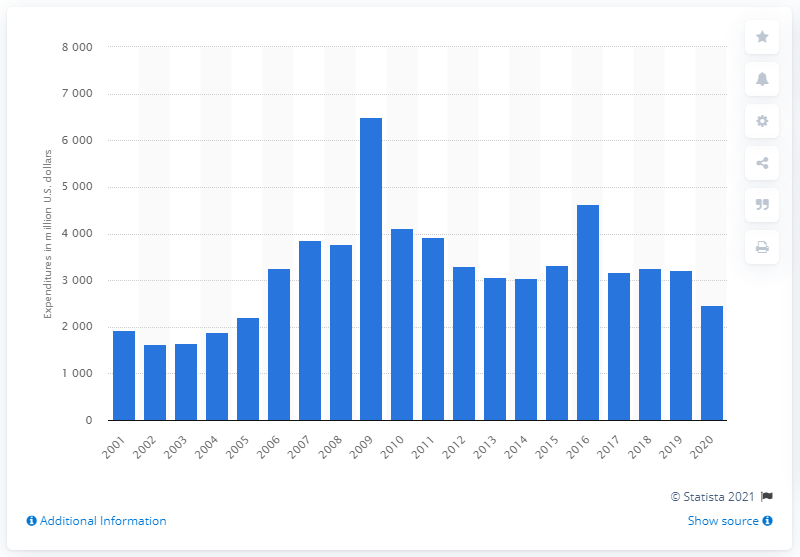How does the expenditure on research and development in the early 2000s compare to the 2010s? Looking at the chart, the early 2000s show a gradual increase in research and development expenditure, while the 2010s display more variation with spikes and dips, although the general trend seems to be an upward trajectory in the longer term. 